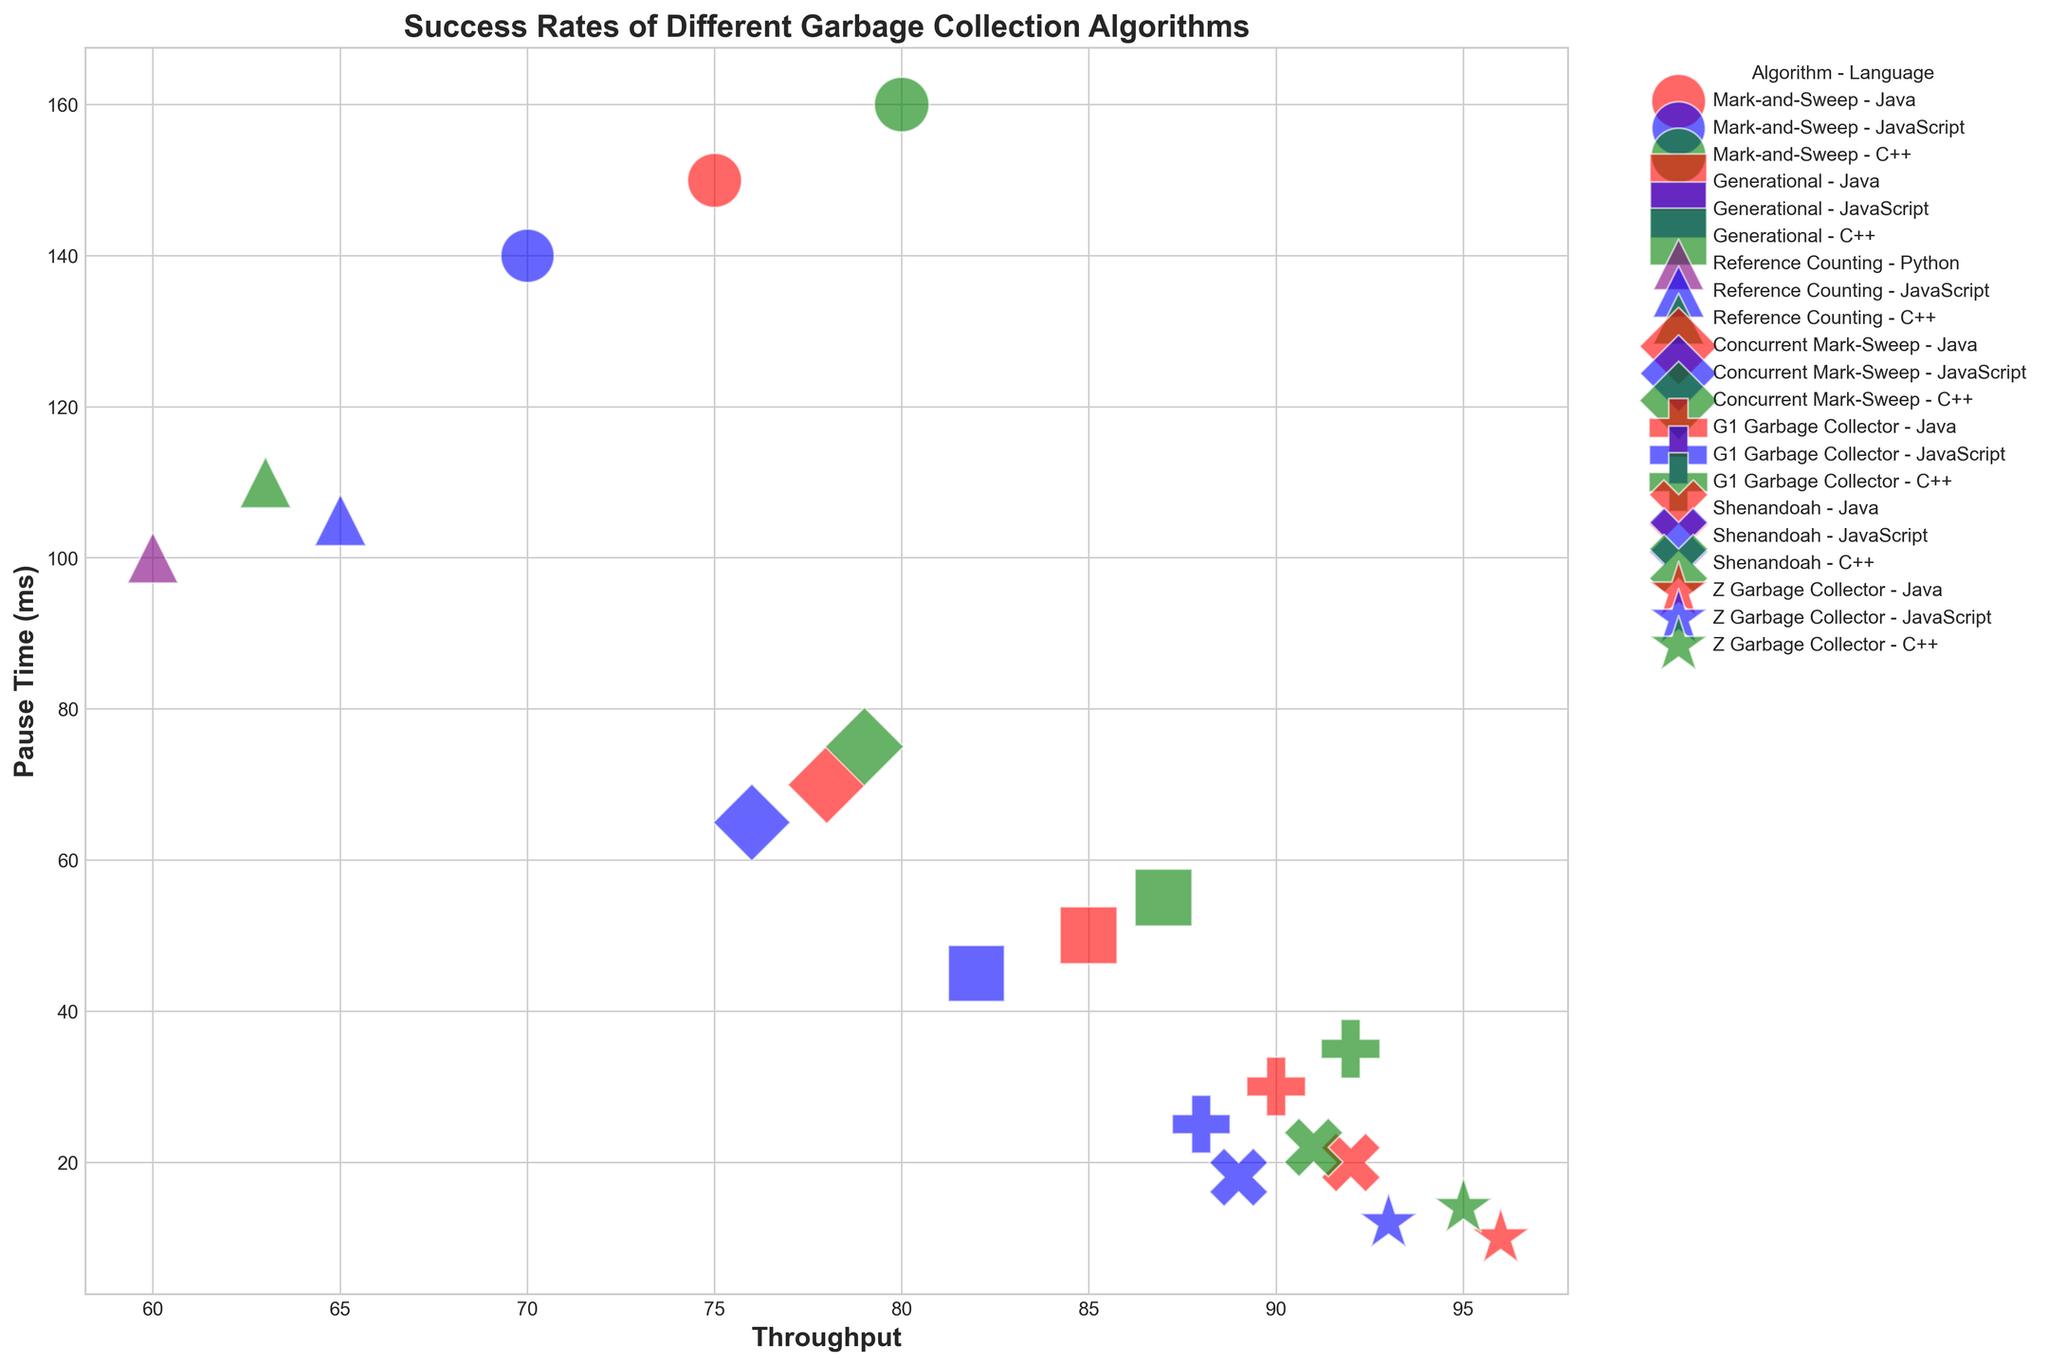What is the throughput of the Z Garbage Collector in Java? First, look for the Z Garbage Collector in the legend and locate its marker shape on the plot. Then find the marker in red color, representing Java, and check its x-position on the Throughput axis.
Answer: 96 Which algorithm has the highest success rate with the lowest pause time? Identify the data points with the lowest pause times on the y-axis, then check their success rates. The Z Garbage Collector in Java has both the highest success rate (98) and the lowest pause time (10 ms).
Answer: Z Garbage Collector in Java Compare the success rates of Mark-and-Sweep and Generational algorithms in JavaScript. Which one is higher? Locate the Mark-and-Sweep (blue circle) and Generational (blue square) in the legend, and then check their success rates. The Generational algorithm has a success rate of 86, while Mark-and-Sweep has 78.
Answer: Generational Which programming language has the highest throughput for the G1 Garbage Collector, and what is the value? Locate the G1 Garbage Collector marker shape and find the data points in red, blue, and green. Identify the marker with the highest throughput value on the x-axis; in this case, it is in C++ with a value of 92.
Answer: C++, 92 What is the average success rate of the Shenandoah algorithm across all programming languages? Identify all Shenandoah markers in the plot, which will be the same shape. Note their success rates: 95 (Java), 93 (JavaScript), and 94 (C++). Calculate the average: (95 + 93 + 94) / 3 = 94.
Answer: 94 How does the pause time of Reference Counting in Python compare with its pause time in JavaScript? Locate the Reference Counting markers for Python (purple) and JavaScript (blue). Python has a pause time of 100 ms and JavaScript has a pause time of 105 ms.
Answer: Python has a shorter pause time Which algorithm-language combination has the highest throughput and what is its success rate? Identify the data point with the highest value on the x-axis, which is the Z Garbage Collector in Java with a throughput of 96. The success rate for this combination is 98.
Answer: Z Garbage Collector in Java, 98 What is the total success rate of Concurrent Mark-Sweep across all languages? Identify all Concurrent Mark-Sweep data points from the legend. Note their success rates for Java (83), JavaScript (81), and C++ (84). Sum these values: 83 + 81 + 84 = 248.
Answer: 248 Which algorithm has the lowest latency in JavaScript and what is its pause time? Locate all data points for JavaScript, then identify the point with the lowest y-position for latency. The Z Garbage Collector has the lowest latency (25 ms) and its pause time is 12 ms.
Answer: Z Garbage Collector, 12 Between Java and C++, which language shows a higher success rate for the Mark-and-Sweep algorithm? Compare the success rates of Mark-and-Sweep in Java (80) and C++ (82) by referring to the legend and matching markers.
Answer: C++ 